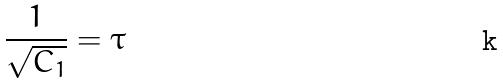<formula> <loc_0><loc_0><loc_500><loc_500>\frac { 1 } { \sqrt { C _ { 1 } } } = \tau</formula> 